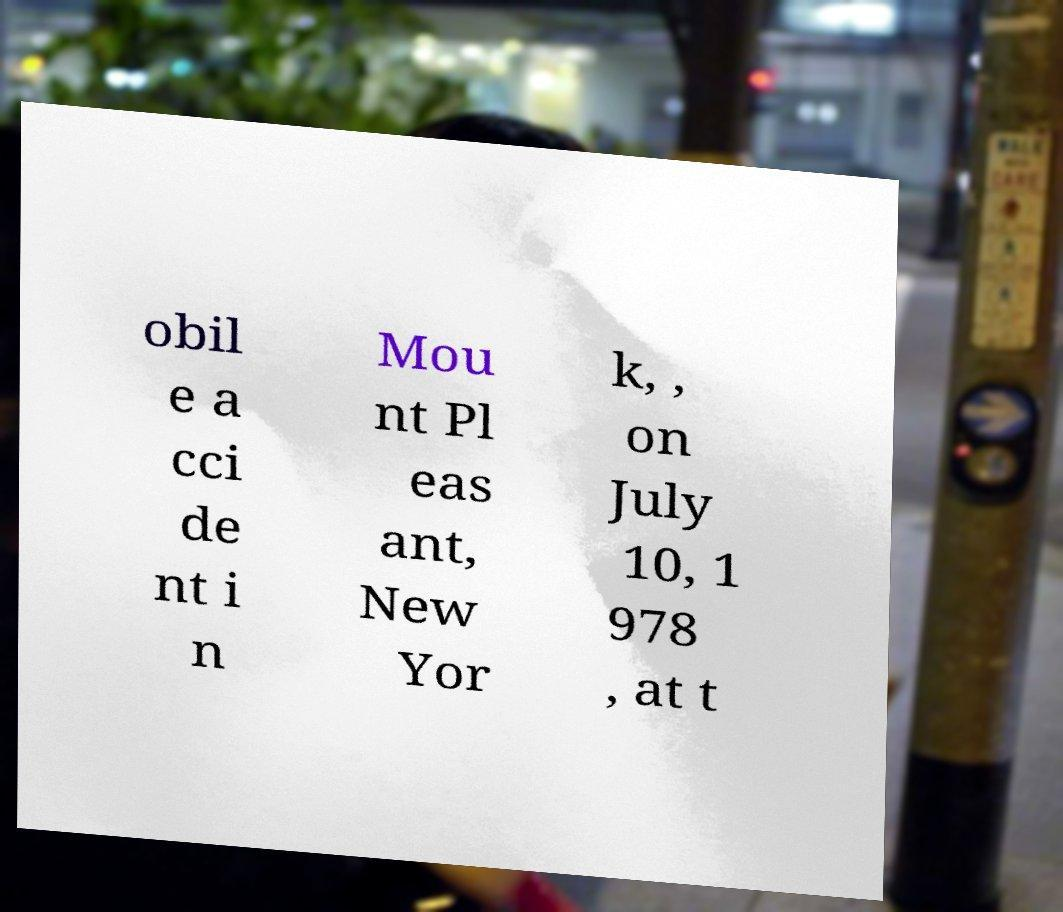I need the written content from this picture converted into text. Can you do that? obil e a cci de nt i n Mou nt Pl eas ant, New Yor k, , on July 10, 1 978 , at t 